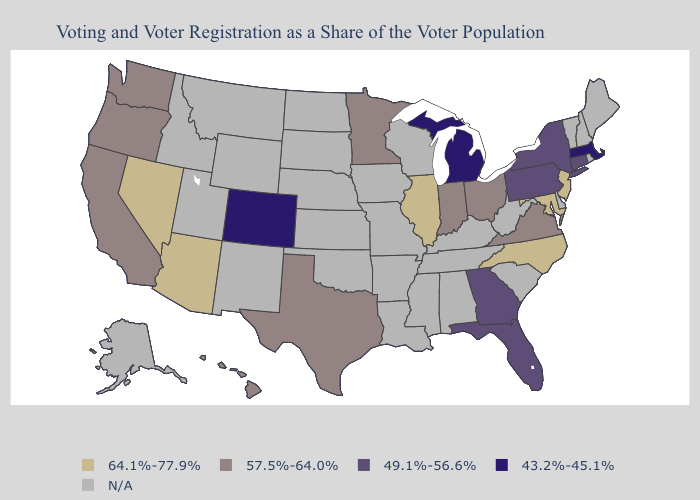What is the highest value in the West ?
Quick response, please. 64.1%-77.9%. What is the lowest value in states that border Michigan?
Short answer required. 57.5%-64.0%. What is the highest value in states that border South Carolina?
Give a very brief answer. 64.1%-77.9%. Among the states that border Georgia , does North Carolina have the highest value?
Concise answer only. Yes. What is the value of Oregon?
Answer briefly. 57.5%-64.0%. What is the value of Wisconsin?
Give a very brief answer. N/A. What is the value of Massachusetts?
Concise answer only. 43.2%-45.1%. Which states have the lowest value in the USA?
Short answer required. Colorado, Massachusetts, Michigan. Name the states that have a value in the range N/A?
Write a very short answer. Alabama, Alaska, Arkansas, Delaware, Idaho, Iowa, Kansas, Kentucky, Louisiana, Maine, Mississippi, Missouri, Montana, Nebraska, New Hampshire, New Mexico, North Dakota, Oklahoma, Rhode Island, South Carolina, South Dakota, Tennessee, Utah, Vermont, West Virginia, Wisconsin, Wyoming. Is the legend a continuous bar?
Short answer required. No. Name the states that have a value in the range 43.2%-45.1%?
Be succinct. Colorado, Massachusetts, Michigan. What is the value of New Jersey?
Quick response, please. 64.1%-77.9%. Which states hav the highest value in the MidWest?
Write a very short answer. Illinois. What is the value of Arizona?
Keep it brief. 64.1%-77.9%. Name the states that have a value in the range 49.1%-56.6%?
Be succinct. Connecticut, Florida, Georgia, New York, Pennsylvania. 